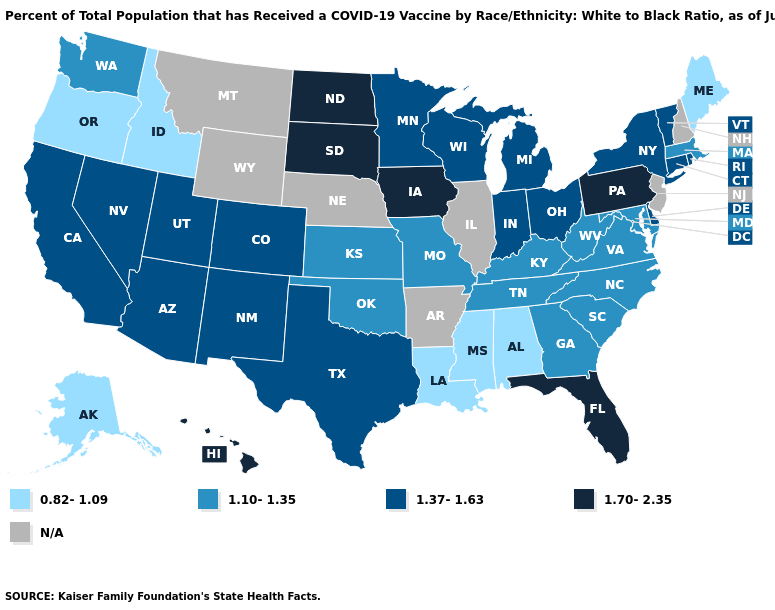What is the highest value in states that border Wisconsin?
Quick response, please. 1.70-2.35. Which states have the lowest value in the USA?
Answer briefly. Alabama, Alaska, Idaho, Louisiana, Maine, Mississippi, Oregon. What is the value of New Mexico?
Keep it brief. 1.37-1.63. What is the value of Texas?
Be succinct. 1.37-1.63. Among the states that border Kansas , which have the lowest value?
Write a very short answer. Missouri, Oklahoma. Does Massachusetts have the highest value in the USA?
Be succinct. No. Name the states that have a value in the range 1.37-1.63?
Answer briefly. Arizona, California, Colorado, Connecticut, Delaware, Indiana, Michigan, Minnesota, Nevada, New Mexico, New York, Ohio, Rhode Island, Texas, Utah, Vermont, Wisconsin. What is the value of Minnesota?
Be succinct. 1.37-1.63. Name the states that have a value in the range 1.70-2.35?
Quick response, please. Florida, Hawaii, Iowa, North Dakota, Pennsylvania, South Dakota. What is the lowest value in the MidWest?
Short answer required. 1.10-1.35. Among the states that border Oklahoma , does Texas have the lowest value?
Be succinct. No. Name the states that have a value in the range 1.70-2.35?
Short answer required. Florida, Hawaii, Iowa, North Dakota, Pennsylvania, South Dakota. Does Oklahoma have the highest value in the South?
Keep it brief. No. 